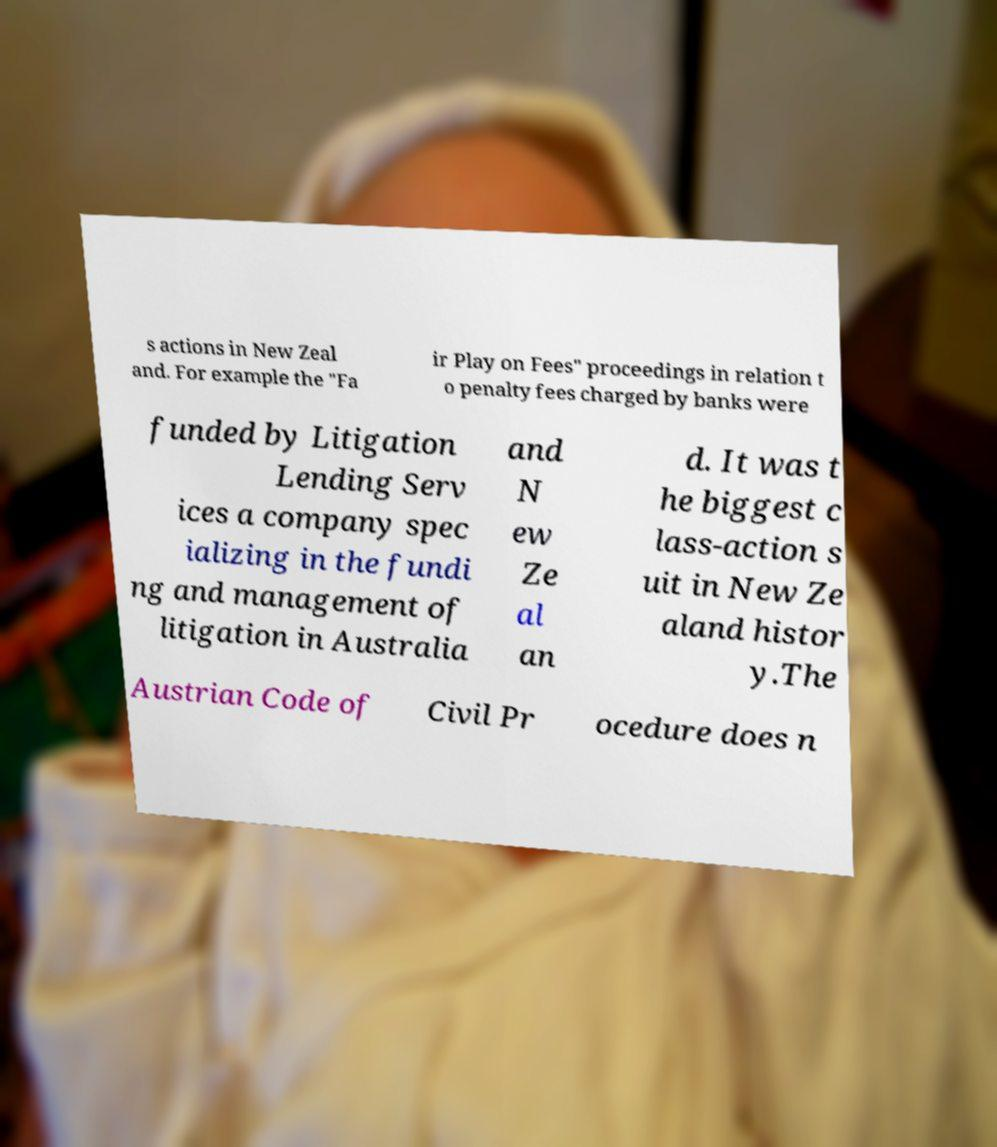Could you extract and type out the text from this image? s actions in New Zeal and. For example the "Fa ir Play on Fees" proceedings in relation t o penalty fees charged by banks were funded by Litigation Lending Serv ices a company spec ializing in the fundi ng and management of litigation in Australia and N ew Ze al an d. It was t he biggest c lass-action s uit in New Ze aland histor y.The Austrian Code of Civil Pr ocedure does n 